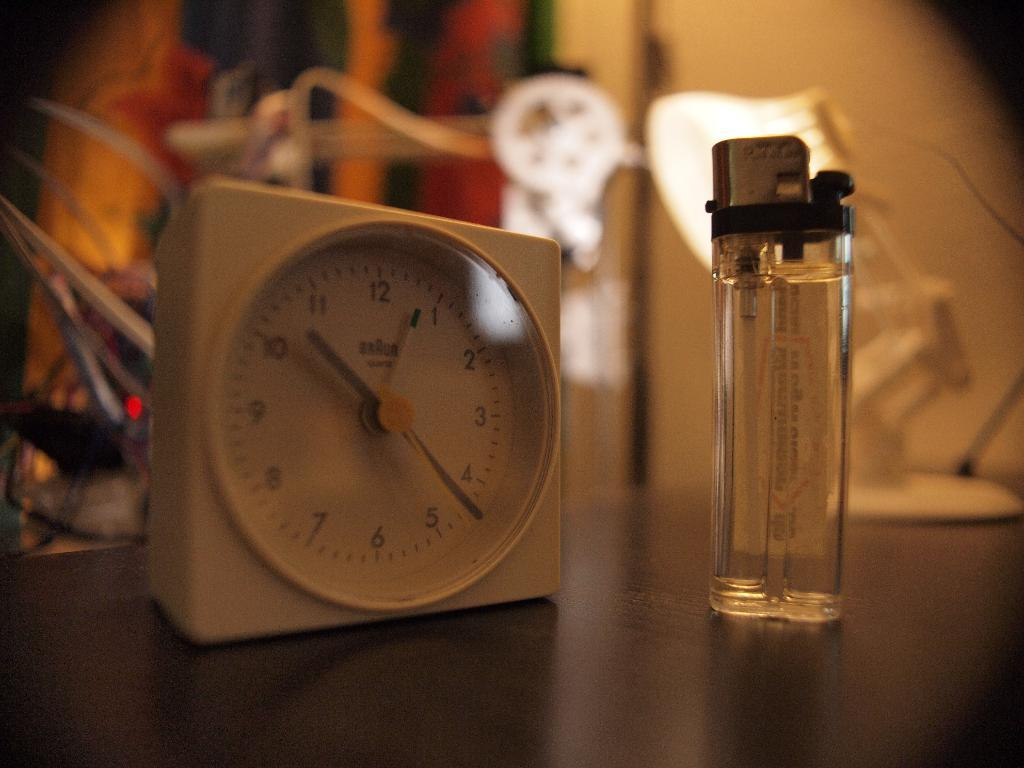<image>
Present a compact description of the photo's key features. A lighter stands next to a Braun clock that shows the time as 10:22. 